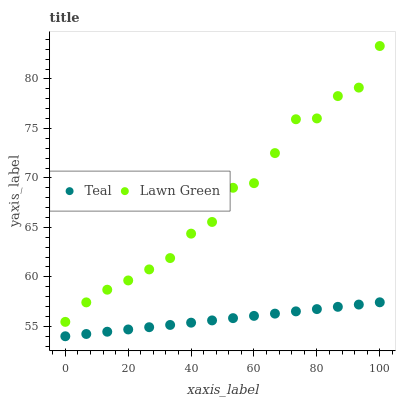Does Teal have the minimum area under the curve?
Answer yes or no. Yes. Does Lawn Green have the maximum area under the curve?
Answer yes or no. Yes. Does Teal have the maximum area under the curve?
Answer yes or no. No. Is Teal the smoothest?
Answer yes or no. Yes. Is Lawn Green the roughest?
Answer yes or no. Yes. Is Teal the roughest?
Answer yes or no. No. Does Teal have the lowest value?
Answer yes or no. Yes. Does Lawn Green have the highest value?
Answer yes or no. Yes. Does Teal have the highest value?
Answer yes or no. No. Is Teal less than Lawn Green?
Answer yes or no. Yes. Is Lawn Green greater than Teal?
Answer yes or no. Yes. Does Teal intersect Lawn Green?
Answer yes or no. No. 